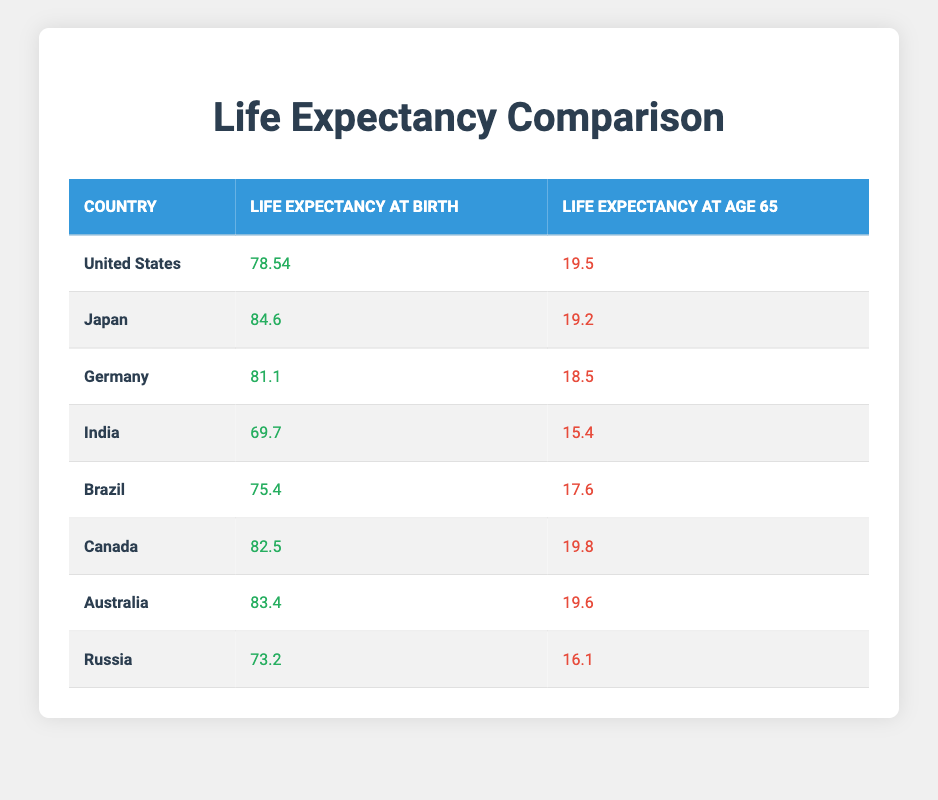What is the life expectancy at birth for Japan? The table shows that Japan has a life expectancy at birth of 84.6 years, which can be found directly in the respective column for Japan.
Answer: 84.6 Which country has the highest life expectancy at age 65? By examining the "Life Expectancy at Age 65" column, Canada has the highest value at 19.8 years.
Answer: Canada What is the difference in life expectancy at birth between the United States and India? The life expectancy at birth for the United States is 78.54 years, while for India it is 69.7 years. The difference is calculated as 78.54 - 69.7 = 8.84 years.
Answer: 8.84 Is it true that Brazil has a higher life expectancy at age 65 than Russia? Brazil's life expectancy at age 65 is 17.6 years, while Russia’s is 16.1 years. Since 17.6 is greater than 16.1, the statement is true.
Answer: Yes What is the average life expectancy at birth for the countries listed in the table? To find the average, sum the life expectancies at birth: 78.54 + 84.6 + 81.1 + 69.7 + 75.4 + 82.5 + 83.4 + 73.2 =  628.1. Then divide by 8 (the number of countries), which results in 628.1 / 8 = 78.5125, approximately 78.51 years.
Answer: 78.51 What is the life expectancy at age 65 for Germany? The table states that Germany has a life expectancy at age 65 of 18.5 years. This information is located directly in the table under Germany's row.
Answer: 18.5 Which country has a life expectancy at birth between 75 and 80 years? The countries meeting this criterion are the United States (78.54) and Brazil (75.4). This can be seen by checking the life expectancy at birth values in the respective rows for each country.
Answer: United States, Brazil If we were to list the countries in order of life expectancy at birth from highest to lowest, what would be the top three countries? The top three countries by life expectancy at birth are Japan (84.6), Canada (82.5), and Germany (81.1). This is determined by looking at the "Life Expectancy at Birth" column and sorting the values.
Answer: Japan, Canada, Germany 